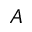Convert formula to latex. <formula><loc_0><loc_0><loc_500><loc_500>A</formula> 